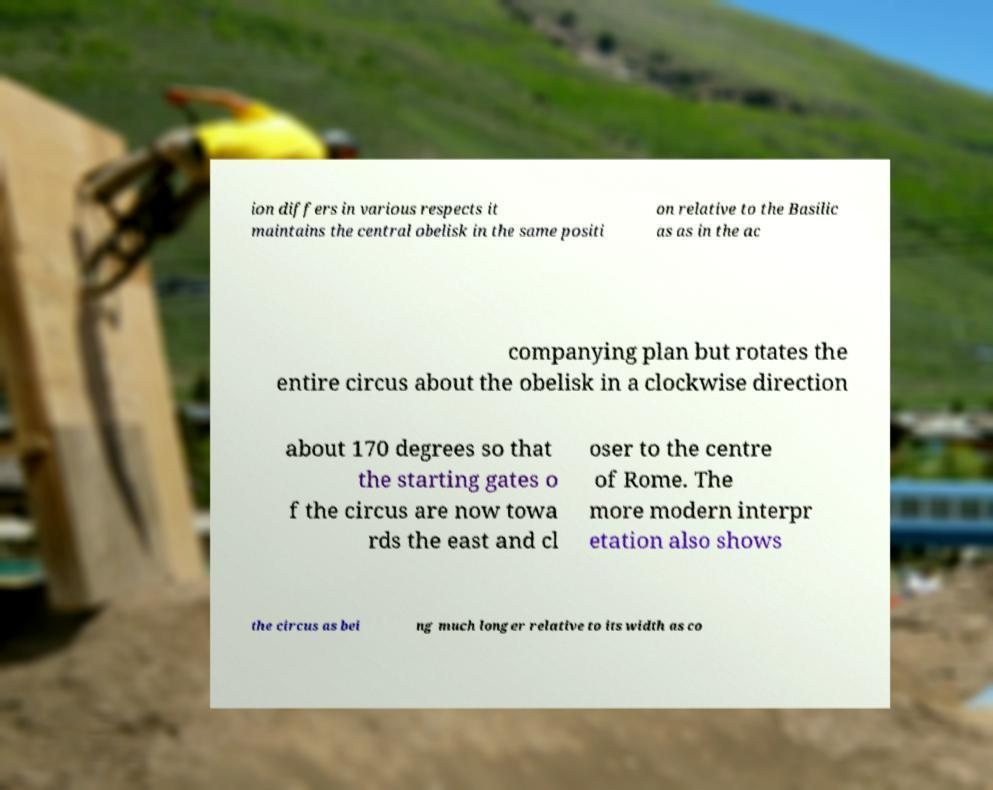Please identify and transcribe the text found in this image. ion differs in various respects it maintains the central obelisk in the same positi on relative to the Basilic as as in the ac companying plan but rotates the entire circus about the obelisk in a clockwise direction about 170 degrees so that the starting gates o f the circus are now towa rds the east and cl oser to the centre of Rome. The more modern interpr etation also shows the circus as bei ng much longer relative to its width as co 